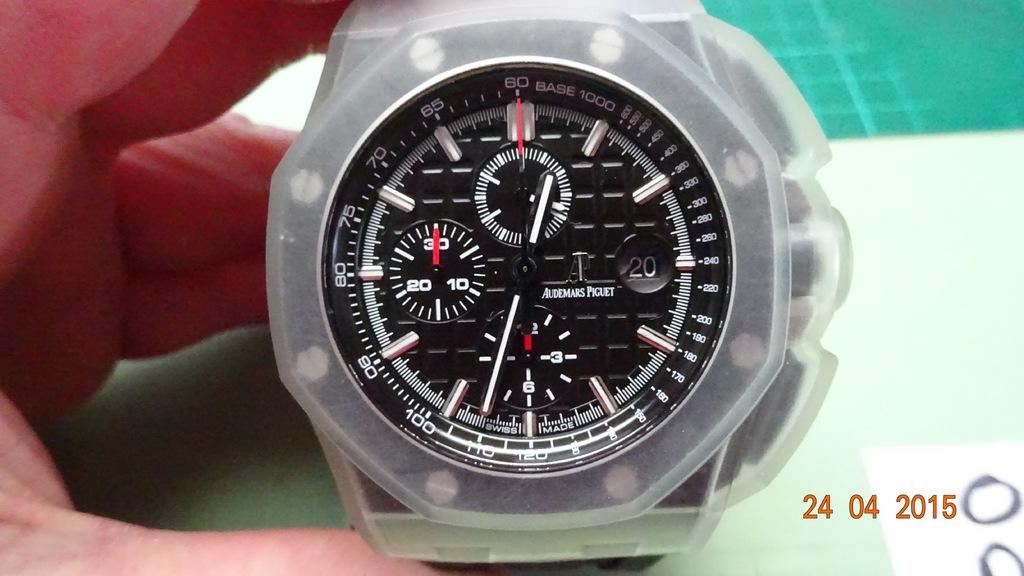What is the date on the photo?
Your answer should be very brief. 24 04 2015. Whats the name of the company that makes the watch?
Provide a short and direct response. Unanswerable. 